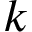<formula> <loc_0><loc_0><loc_500><loc_500>k</formula> 